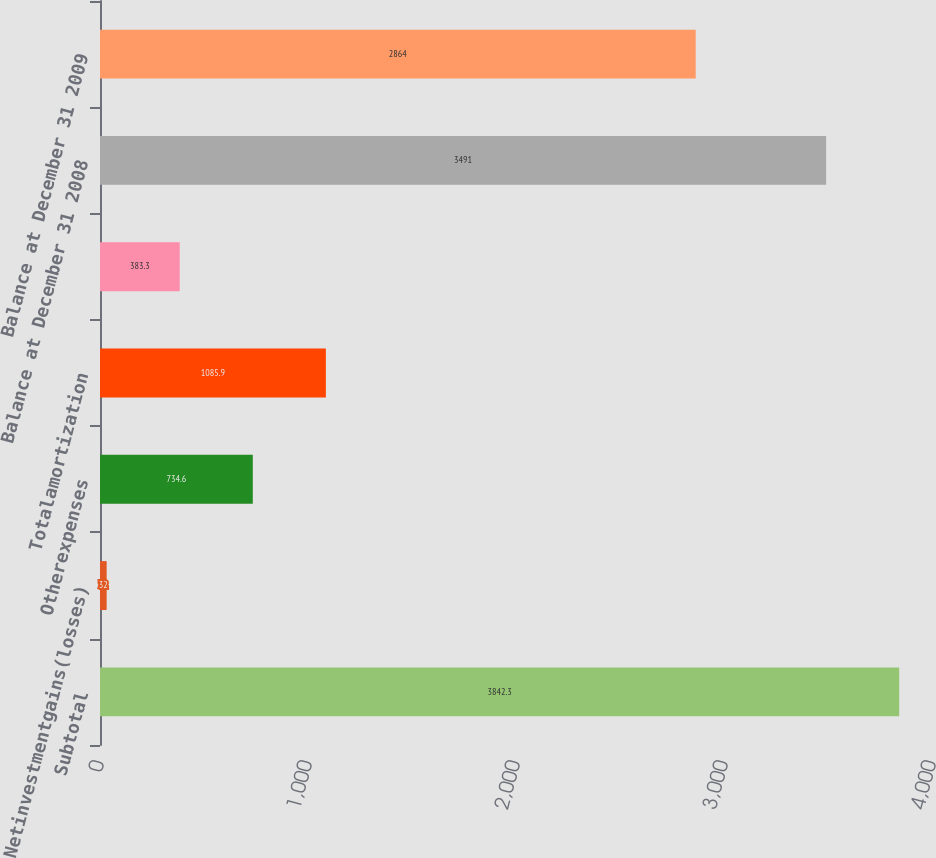Convert chart. <chart><loc_0><loc_0><loc_500><loc_500><bar_chart><fcel>Subtotal<fcel>Netinvestmentgains(losses)<fcel>Otherexpenses<fcel>Totalamortization<fcel>Unnamed: 4<fcel>Balance at December 31 2008<fcel>Balance at December 31 2009<nl><fcel>3842.3<fcel>32<fcel>734.6<fcel>1085.9<fcel>383.3<fcel>3491<fcel>2864<nl></chart> 